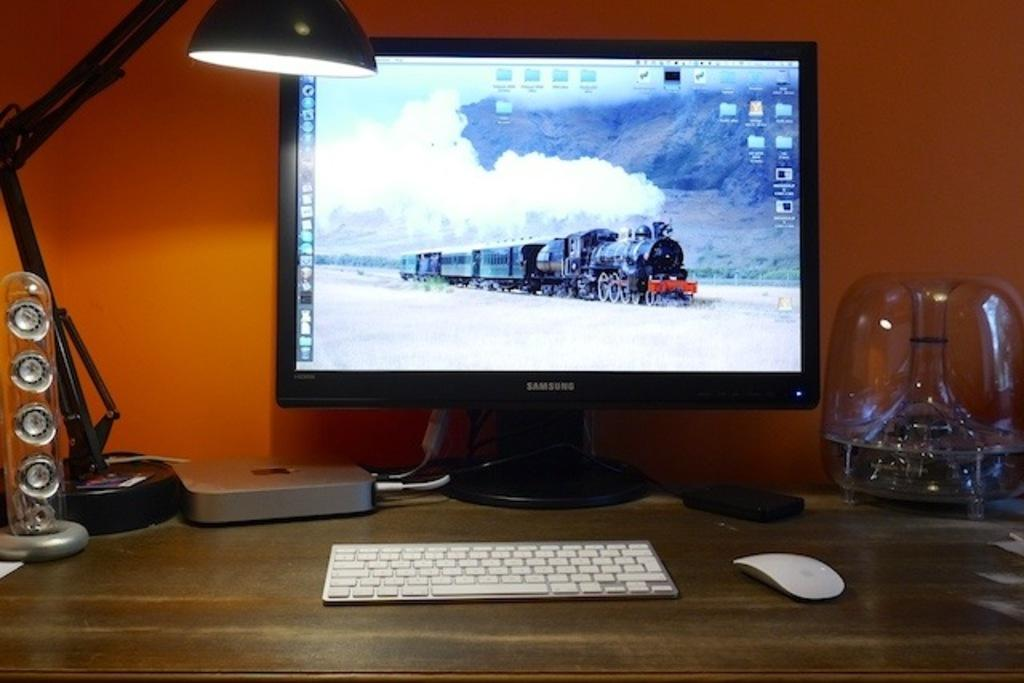<image>
Offer a succinct explanation of the picture presented. A Samsung monitor is showing a photo of a steam locomotive. 